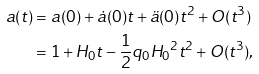Convert formula to latex. <formula><loc_0><loc_0><loc_500><loc_500>a ( t ) & = a ( 0 ) + \dot { a } ( 0 ) t + \ddot { a } ( 0 ) t ^ { 2 } + O ( t ^ { 3 } ) \\ & = 1 + H _ { 0 } t - \frac { 1 } { 2 } q _ { 0 } { H _ { 0 } } ^ { 2 } t ^ { 2 } + O ( t ^ { 3 } ) ,</formula> 